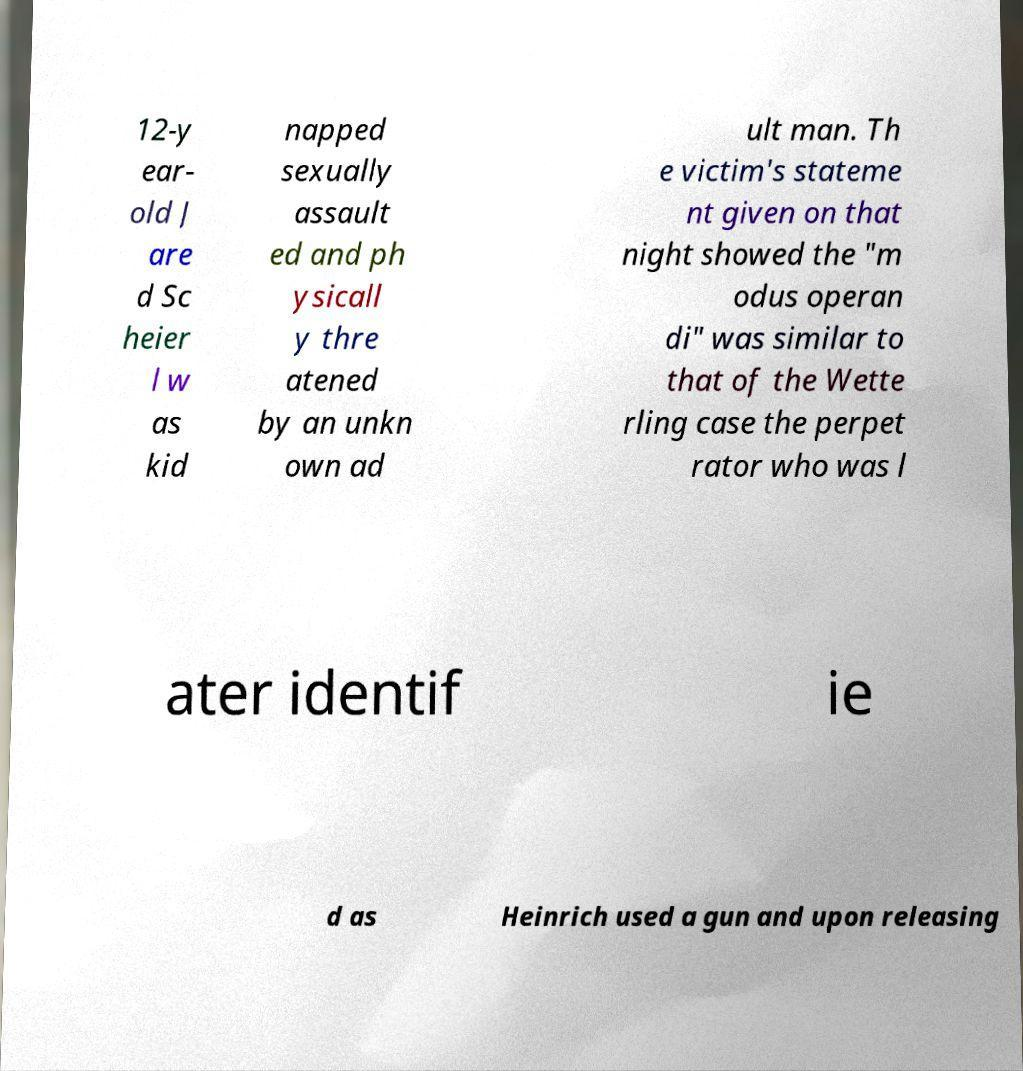Please identify and transcribe the text found in this image. 12-y ear- old J are d Sc heier l w as kid napped sexually assault ed and ph ysicall y thre atened by an unkn own ad ult man. Th e victim's stateme nt given on that night showed the "m odus operan di" was similar to that of the Wette rling case the perpet rator who was l ater identif ie d as Heinrich used a gun and upon releasing 